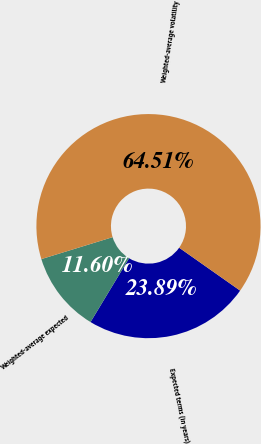Convert chart. <chart><loc_0><loc_0><loc_500><loc_500><pie_chart><fcel>Expected terms (in years)<fcel>Weighted-average expected<fcel>Weighted-average volatility<nl><fcel>23.89%<fcel>11.6%<fcel>64.51%<nl></chart> 